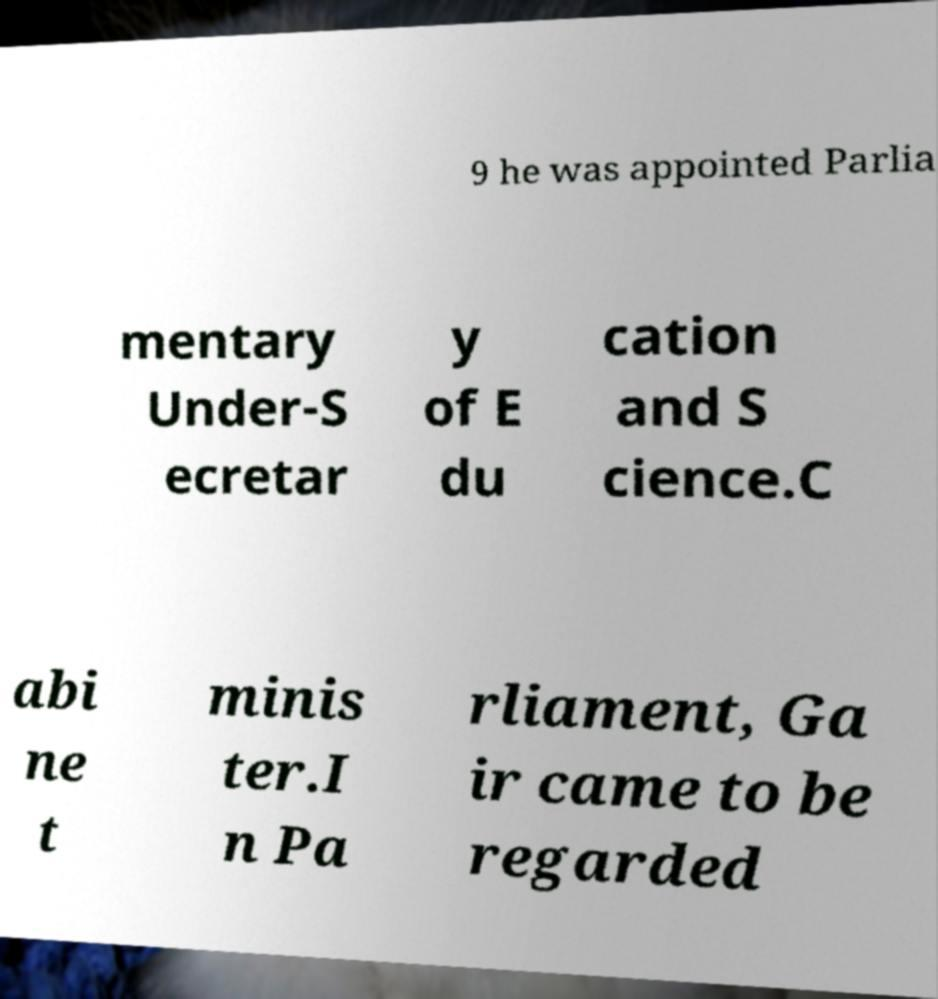For documentation purposes, I need the text within this image transcribed. Could you provide that? 9 he was appointed Parlia mentary Under-S ecretar y of E du cation and S cience.C abi ne t minis ter.I n Pa rliament, Ga ir came to be regarded 